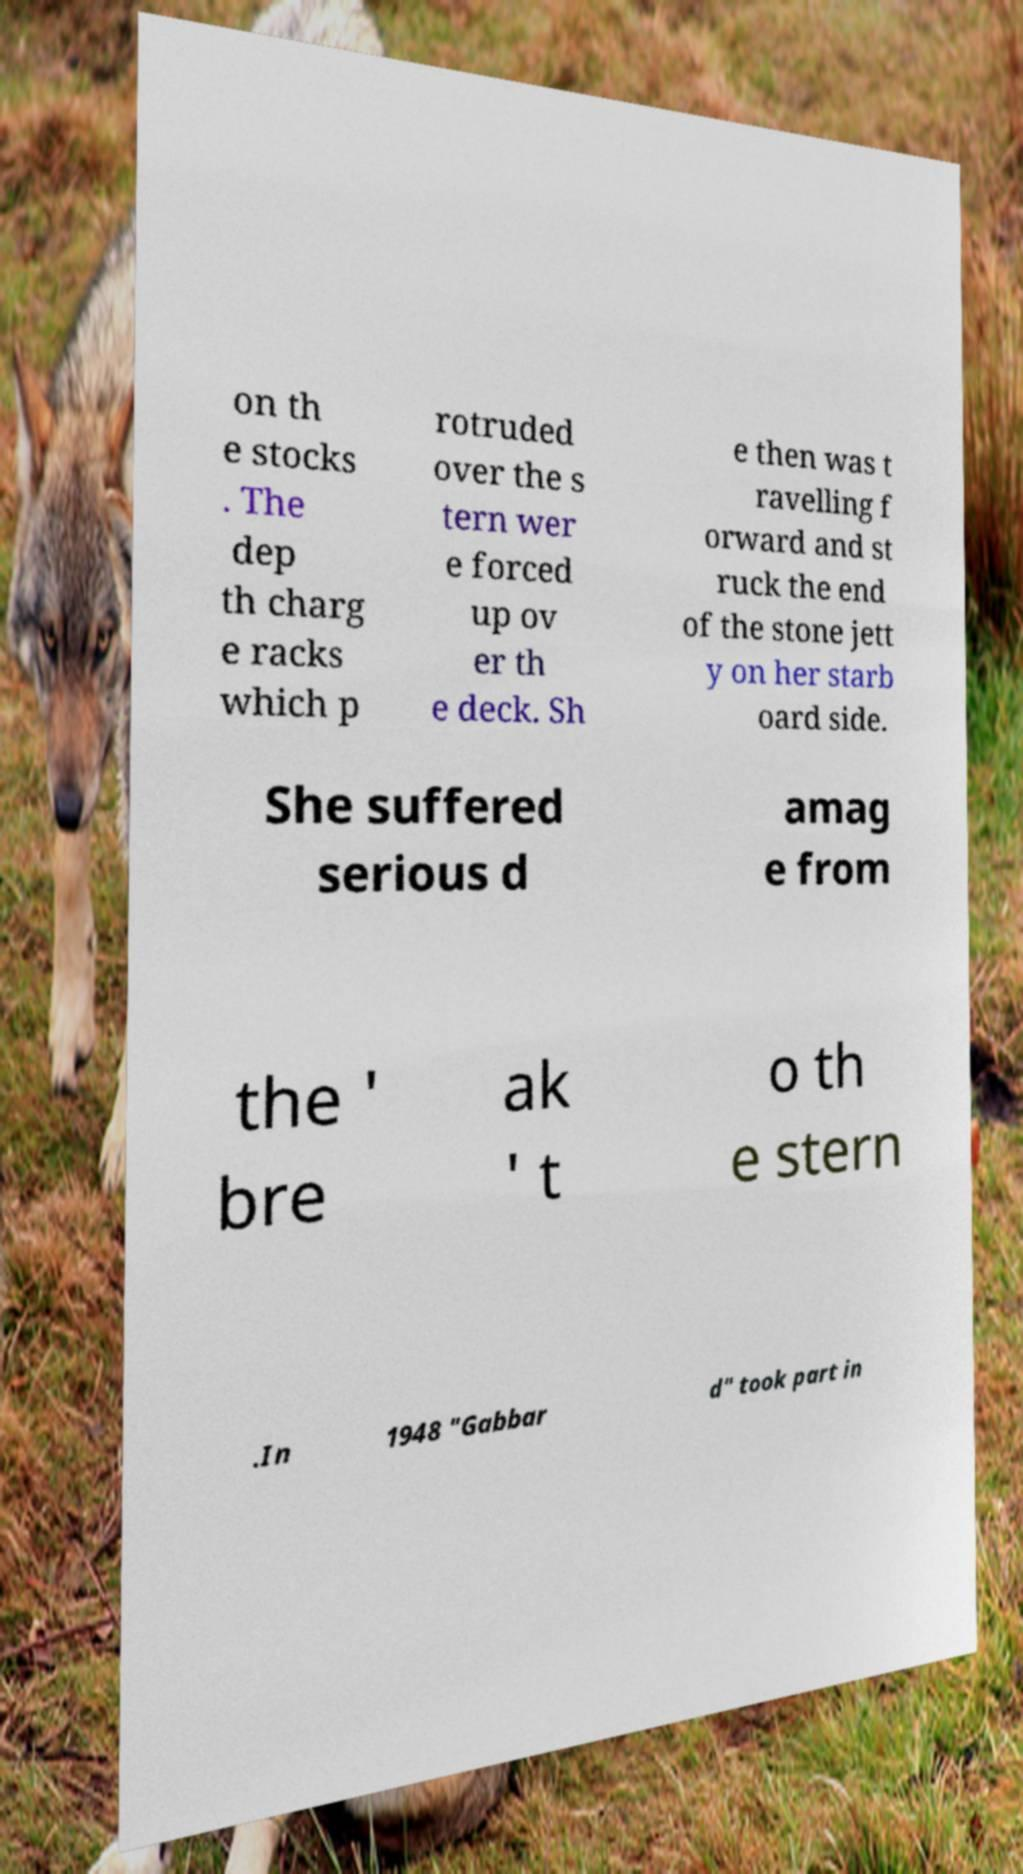Can you read and provide the text displayed in the image?This photo seems to have some interesting text. Can you extract and type it out for me? on th e stocks . The dep th charg e racks which p rotruded over the s tern wer e forced up ov er th e deck. Sh e then was t ravelling f orward and st ruck the end of the stone jett y on her starb oard side. She suffered serious d amag e from the ' bre ak ' t o th e stern .In 1948 "Gabbar d" took part in 